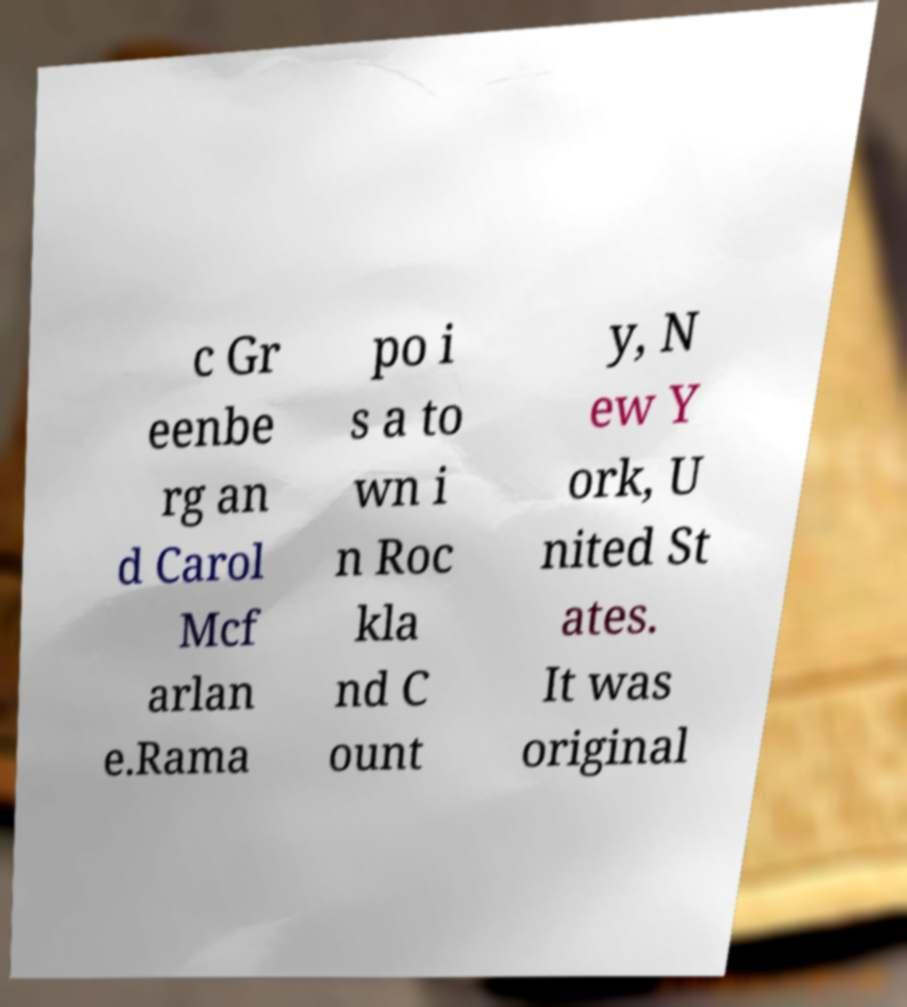There's text embedded in this image that I need extracted. Can you transcribe it verbatim? c Gr eenbe rg an d Carol Mcf arlan e.Rama po i s a to wn i n Roc kla nd C ount y, N ew Y ork, U nited St ates. It was original 